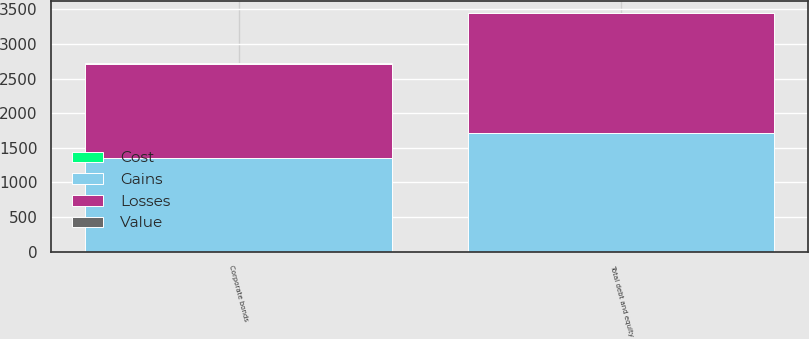Convert chart. <chart><loc_0><loc_0><loc_500><loc_500><stacked_bar_chart><ecel><fcel>Corporate bonds<fcel>Total debt and equity<nl><fcel>Losses<fcel>1359<fcel>1725<nl><fcel>Cost<fcel>2<fcel>2<nl><fcel>Value<fcel>8<fcel>9<nl><fcel>Gains<fcel>1353<fcel>1718<nl></chart> 